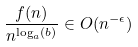<formula> <loc_0><loc_0><loc_500><loc_500>\frac { f ( n ) } { n ^ { \log _ { a } ( b ) } } \in O ( n ^ { - \epsilon } )</formula> 